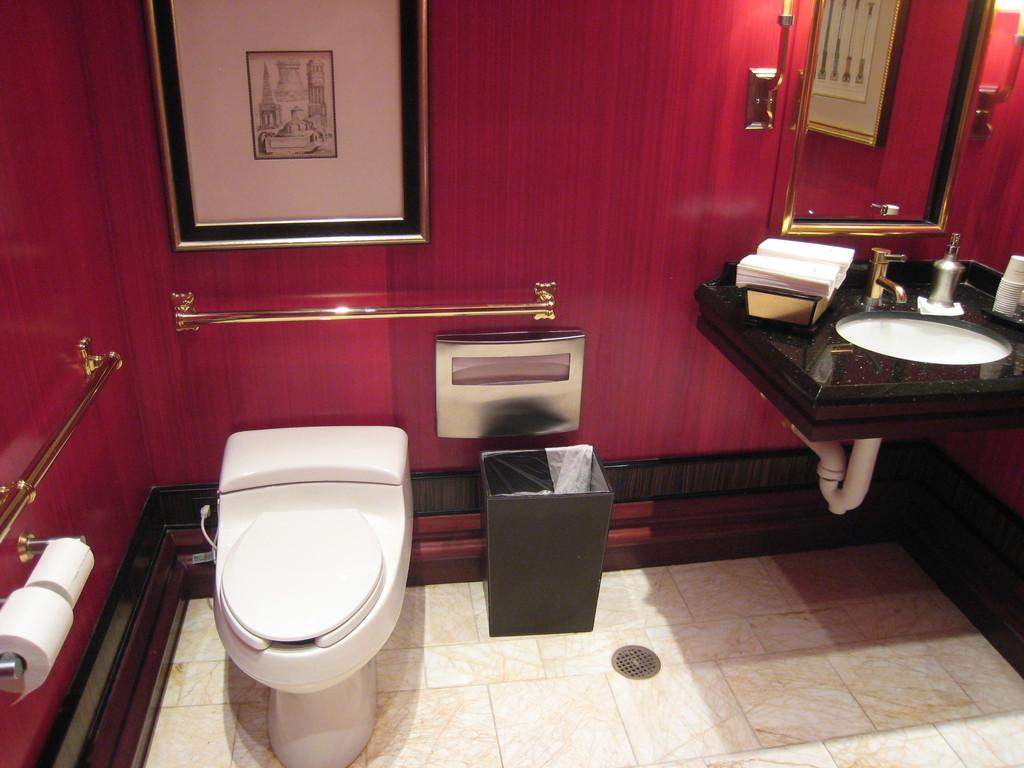What type of room is depicted in the image? There is a washroom in the image. What can be found inside the washroom? There is a toilet seat, a wash basin, a tissue roll, and a mirror in the washroom. Is there any decoration on the wall in the washroom? Yes, there is a photo frame on the wall in the washroom. What is the color of the wall in the washroom? The wall is red in color. Can you see the brain of the person using the washroom in the image? No, the image does not show the brain of the person using the washroom. Is there a dog present in the washroom in the image? No, there is no dog present in the washroom in the image. 